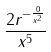Convert formula to latex. <formula><loc_0><loc_0><loc_500><loc_500>\frac { 2 r ^ { - \frac { 0 } { x ^ { 2 } } } } { x ^ { 5 } }</formula> 